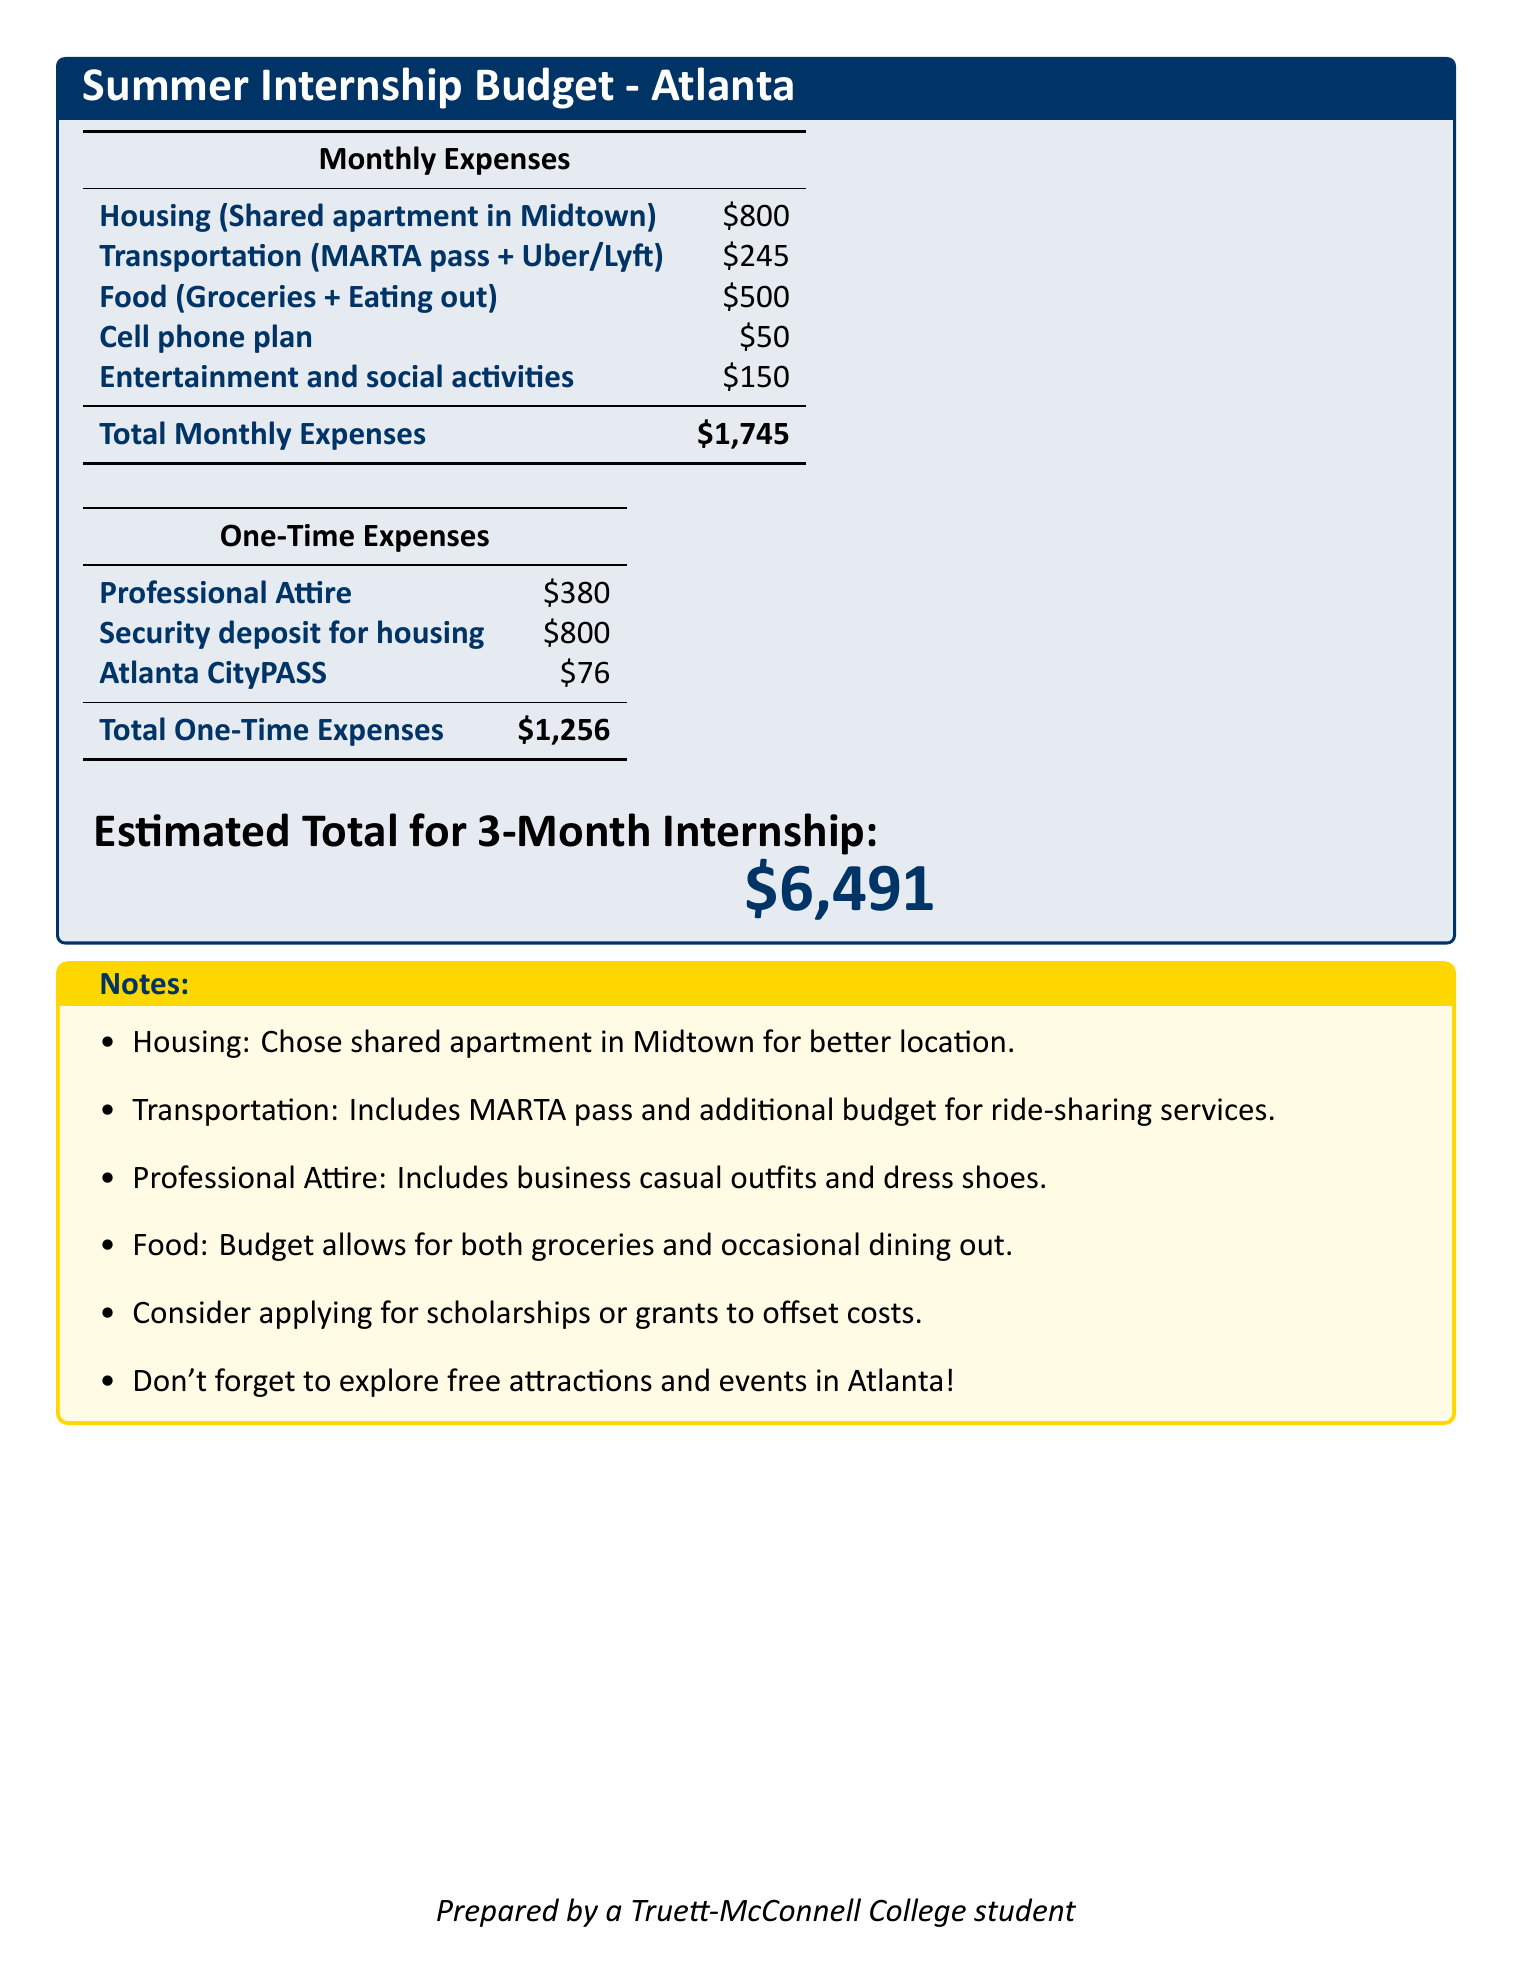What is the total monthly housing expense? The total monthly housing expense for a shared apartment in Midtown is listed as $800.
Answer: $800 How much is the total estimated expense for a 3-month internship? The estimated total expense for the internship is provided at the bottom of the document as $6,491.
Answer: $6,491 What does the transportation expense include? The transportation expense includes a MARTA pass and additional budget for ride-sharing services, as mentioned in the notes.
Answer: MARTA pass and ride-sharing What is the total for one-time expenses? The total for one-time expenses is calculated as $380 (Professional Attire) + $800 (Security deposit) + $76 (Atlanta CityPASS) = $1,256.
Answer: $1,256 How much is budgeted for professional attire? The amount budgeted for professional attire is clearly stated as $380 in the one-time expenses section.
Answer: $380 What is the expense for food per month? The monthly expense for food, including groceries and eating out, is specified as $500.
Answer: $500 How much is budgeted for entertainment and social activities? The budget for entertainment and social activities is listed as $150 per month in the monthly expenses section.
Answer: $150 What should you consider to offset costs? The notes suggest considering scholarships or grants to help offset costs during the internship.
Answer: Scholarships or grants Where is the housing option located? The document specifies that the housing option chosen is a shared apartment in Midtown, indicating the location.
Answer: Midtown 